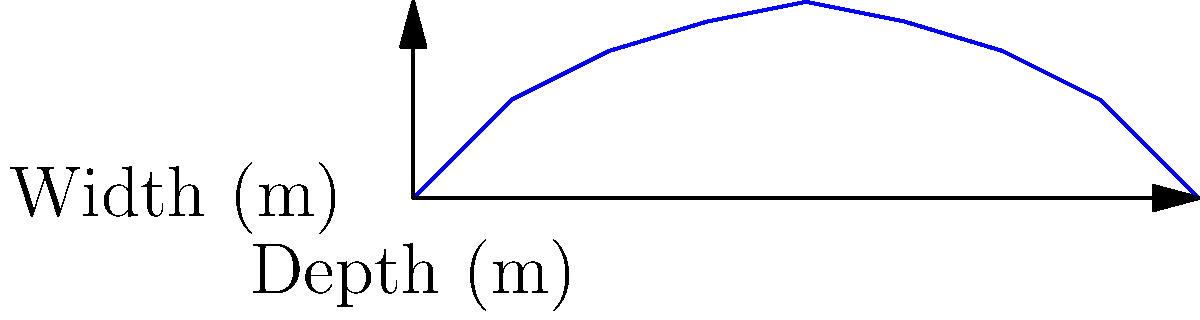As a forest ranger supervisor, you're assessing a stream for potential guided tour activities. Given the cross-sectional area shown in the diagram and an average velocity of 0.75 m/s, estimate the water flow rate in the stream. Round your answer to the nearest whole number in cubic meters per second (m³/s). To estimate the water flow rate, we need to use the continuity equation:

$$ Q = A \times v $$

Where:
$Q$ = flow rate (m³/s)
$A$ = cross-sectional area (m²)
$v$ = average velocity (m/s)

Step 1: Calculate the cross-sectional area
We can approximate the area using the trapezoidal rule:

$$ A = \frac{1}{2}(y_1 + y_n) \times w $$

Where $y_1$ and $y_n$ are the depths at the ends, and $w$ is the width.

$$ A = \frac{1}{2}(0 + 0) \times 8 + 2 \times 8 = 16 \text{ m²} $$

Step 2: Use the given velocity
$v = 0.75 \text{ m/s}$

Step 3: Calculate the flow rate
$$ Q = A \times v = 16 \text{ m²} \times 0.75 \text{ m/s} = 12 \text{ m³/s} $$

Step 4: Round to the nearest whole number
$12 \text{ m³/s}$ is already a whole number, so no rounding is necessary.
Answer: 12 m³/s 